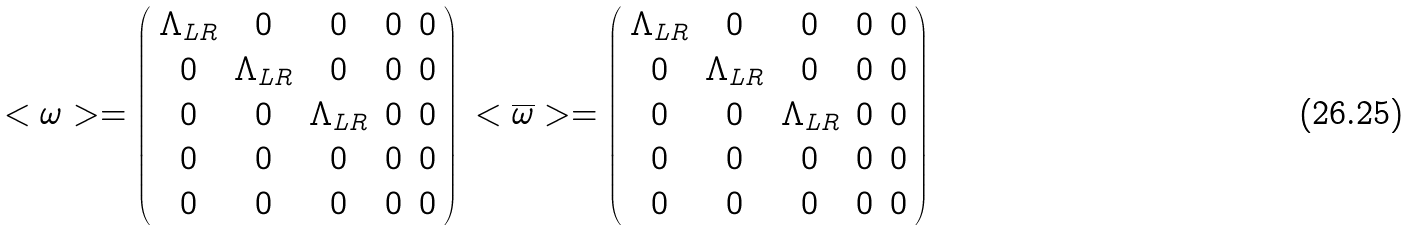<formula> <loc_0><loc_0><loc_500><loc_500>\begin{array} { l l } < \omega > = \left ( \begin{array} { c c c c c } \Lambda _ { L R } & 0 & 0 & 0 & 0 \\ 0 & \Lambda _ { L R } & 0 & 0 & 0 \\ 0 & 0 & \Lambda _ { L R } & 0 & 0 \\ 0 & 0 & 0 & 0 & 0 \\ 0 & 0 & 0 & 0 & 0 \\ \end{array} \right ) & < \overline { \omega } > = \left ( \begin{array} { c c c c c } \Lambda _ { L R } & 0 & 0 & 0 & 0 \\ 0 & \Lambda _ { L R } & 0 & 0 & 0 \\ 0 & 0 & \Lambda _ { L R } & 0 & 0 \\ 0 & 0 & 0 & 0 & 0 \\ 0 & 0 & 0 & 0 & 0 \\ \end{array} \right ) \\ \end{array}</formula> 